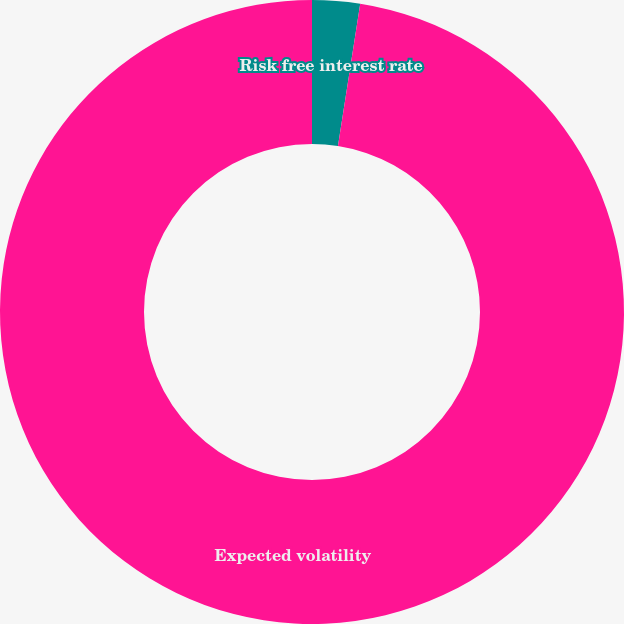<chart> <loc_0><loc_0><loc_500><loc_500><pie_chart><fcel>Risk free interest rate<fcel>Expected volatility<nl><fcel>2.47%<fcel>97.53%<nl></chart> 